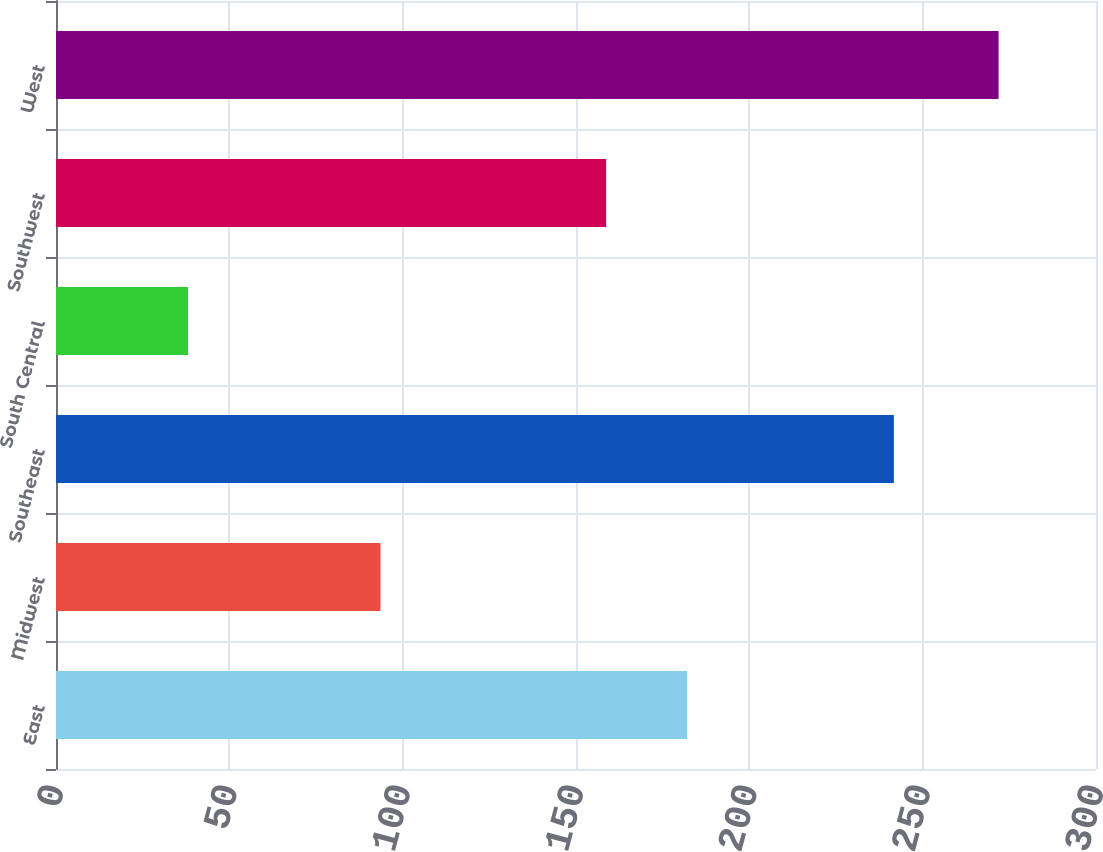Convert chart to OTSL. <chart><loc_0><loc_0><loc_500><loc_500><bar_chart><fcel>East<fcel>Midwest<fcel>Southeast<fcel>South Central<fcel>Southwest<fcel>West<nl><fcel>182.08<fcel>93.6<fcel>241.7<fcel>38.1<fcel>158.7<fcel>271.9<nl></chart> 